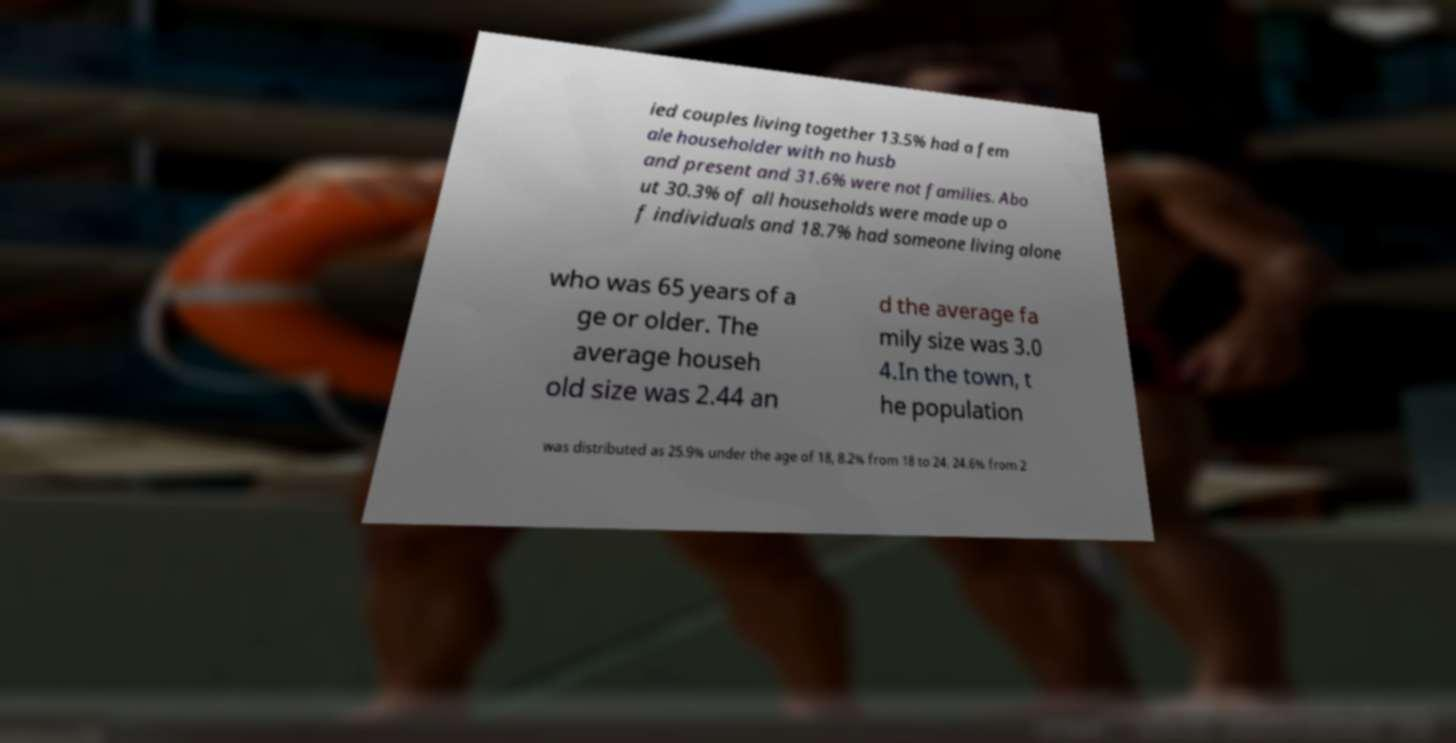I need the written content from this picture converted into text. Can you do that? ied couples living together 13.5% had a fem ale householder with no husb and present and 31.6% were not families. Abo ut 30.3% of all households were made up o f individuals and 18.7% had someone living alone who was 65 years of a ge or older. The average househ old size was 2.44 an d the average fa mily size was 3.0 4.In the town, t he population was distributed as 25.9% under the age of 18, 8.2% from 18 to 24, 24.6% from 2 